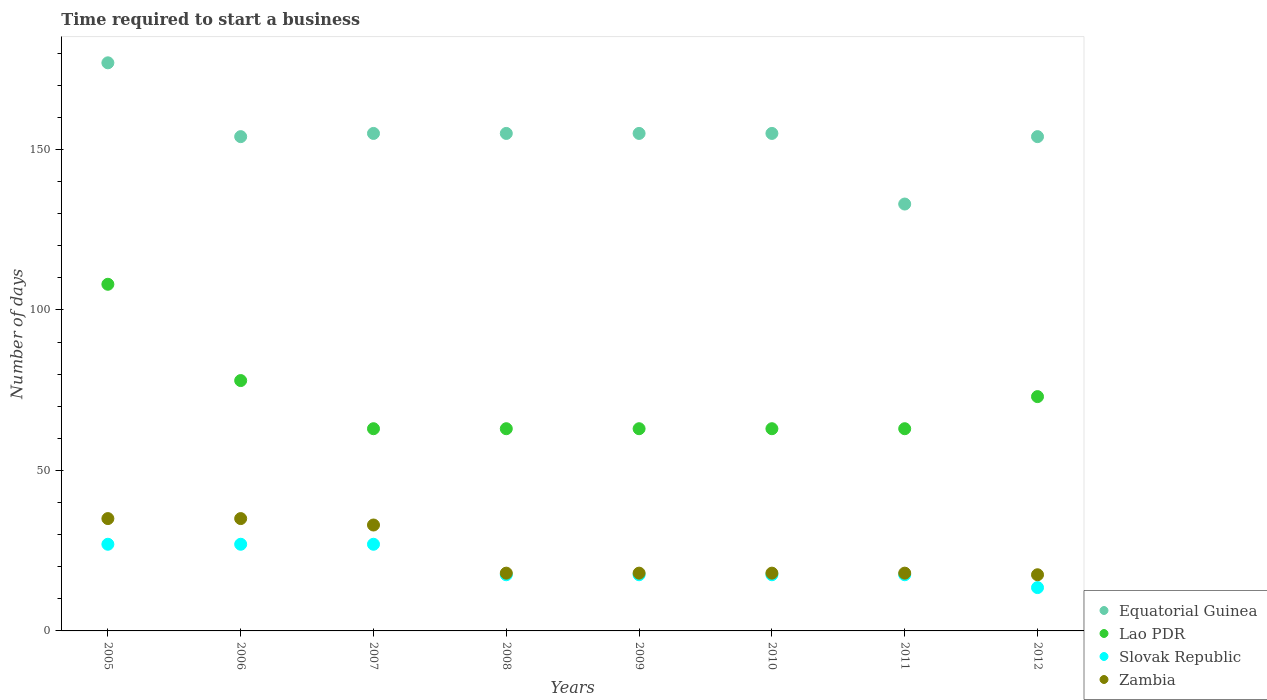What is the number of days required to start a business in Lao PDR in 2007?
Your answer should be very brief. 63. Across all years, what is the maximum number of days required to start a business in Slovak Republic?
Your answer should be very brief. 27. Across all years, what is the minimum number of days required to start a business in Equatorial Guinea?
Make the answer very short. 133. In which year was the number of days required to start a business in Slovak Republic maximum?
Ensure brevity in your answer.  2005. What is the total number of days required to start a business in Lao PDR in the graph?
Provide a succinct answer. 574. What is the difference between the number of days required to start a business in Slovak Republic in 2011 and that in 2012?
Keep it short and to the point. 4. What is the difference between the number of days required to start a business in Equatorial Guinea in 2005 and the number of days required to start a business in Zambia in 2008?
Ensure brevity in your answer.  159. What is the average number of days required to start a business in Lao PDR per year?
Your answer should be compact. 71.75. In the year 2012, what is the difference between the number of days required to start a business in Lao PDR and number of days required to start a business in Slovak Republic?
Your response must be concise. 59.5. What is the ratio of the number of days required to start a business in Zambia in 2007 to that in 2010?
Offer a very short reply. 1.83. Is the number of days required to start a business in Equatorial Guinea in 2006 less than that in 2011?
Your response must be concise. No. Is the difference between the number of days required to start a business in Lao PDR in 2009 and 2010 greater than the difference between the number of days required to start a business in Slovak Republic in 2009 and 2010?
Your answer should be very brief. No. What is the difference between the highest and the second highest number of days required to start a business in Lao PDR?
Offer a very short reply. 30. What is the difference between the highest and the lowest number of days required to start a business in Equatorial Guinea?
Your answer should be very brief. 44. How many dotlines are there?
Your answer should be very brief. 4. How many years are there in the graph?
Your answer should be very brief. 8. What is the difference between two consecutive major ticks on the Y-axis?
Provide a succinct answer. 50. What is the title of the graph?
Offer a very short reply. Time required to start a business. Does "Jordan" appear as one of the legend labels in the graph?
Your answer should be compact. No. What is the label or title of the Y-axis?
Make the answer very short. Number of days. What is the Number of days in Equatorial Guinea in 2005?
Offer a terse response. 177. What is the Number of days in Lao PDR in 2005?
Give a very brief answer. 108. What is the Number of days in Equatorial Guinea in 2006?
Keep it short and to the point. 154. What is the Number of days in Lao PDR in 2006?
Provide a short and direct response. 78. What is the Number of days of Slovak Republic in 2006?
Offer a very short reply. 27. What is the Number of days in Equatorial Guinea in 2007?
Give a very brief answer. 155. What is the Number of days in Equatorial Guinea in 2008?
Offer a very short reply. 155. What is the Number of days in Lao PDR in 2008?
Keep it short and to the point. 63. What is the Number of days in Zambia in 2008?
Your answer should be compact. 18. What is the Number of days in Equatorial Guinea in 2009?
Give a very brief answer. 155. What is the Number of days of Lao PDR in 2009?
Offer a very short reply. 63. What is the Number of days in Slovak Republic in 2009?
Your answer should be compact. 17.5. What is the Number of days of Zambia in 2009?
Make the answer very short. 18. What is the Number of days of Equatorial Guinea in 2010?
Provide a succinct answer. 155. What is the Number of days in Slovak Republic in 2010?
Keep it short and to the point. 17.5. What is the Number of days of Zambia in 2010?
Your answer should be compact. 18. What is the Number of days of Equatorial Guinea in 2011?
Your answer should be compact. 133. What is the Number of days of Slovak Republic in 2011?
Provide a succinct answer. 17.5. What is the Number of days of Zambia in 2011?
Make the answer very short. 18. What is the Number of days of Equatorial Guinea in 2012?
Your answer should be compact. 154. What is the Number of days in Lao PDR in 2012?
Your answer should be compact. 73. What is the Number of days of Slovak Republic in 2012?
Your response must be concise. 13.5. What is the Number of days of Zambia in 2012?
Make the answer very short. 17.5. Across all years, what is the maximum Number of days of Equatorial Guinea?
Offer a very short reply. 177. Across all years, what is the maximum Number of days of Lao PDR?
Make the answer very short. 108. Across all years, what is the minimum Number of days of Equatorial Guinea?
Offer a terse response. 133. Across all years, what is the minimum Number of days in Slovak Republic?
Offer a very short reply. 13.5. Across all years, what is the minimum Number of days in Zambia?
Offer a terse response. 17.5. What is the total Number of days in Equatorial Guinea in the graph?
Offer a terse response. 1238. What is the total Number of days of Lao PDR in the graph?
Your response must be concise. 574. What is the total Number of days of Slovak Republic in the graph?
Ensure brevity in your answer.  164.5. What is the total Number of days in Zambia in the graph?
Keep it short and to the point. 192.5. What is the difference between the Number of days in Slovak Republic in 2005 and that in 2006?
Provide a succinct answer. 0. What is the difference between the Number of days of Zambia in 2005 and that in 2006?
Ensure brevity in your answer.  0. What is the difference between the Number of days of Lao PDR in 2005 and that in 2008?
Provide a short and direct response. 45. What is the difference between the Number of days of Slovak Republic in 2005 and that in 2008?
Offer a very short reply. 9.5. What is the difference between the Number of days in Zambia in 2005 and that in 2008?
Offer a very short reply. 17. What is the difference between the Number of days in Equatorial Guinea in 2005 and that in 2009?
Give a very brief answer. 22. What is the difference between the Number of days of Slovak Republic in 2005 and that in 2009?
Your answer should be compact. 9.5. What is the difference between the Number of days of Zambia in 2005 and that in 2009?
Make the answer very short. 17. What is the difference between the Number of days in Zambia in 2005 and that in 2010?
Provide a succinct answer. 17. What is the difference between the Number of days of Equatorial Guinea in 2005 and that in 2011?
Your answer should be compact. 44. What is the difference between the Number of days of Lao PDR in 2005 and that in 2011?
Offer a very short reply. 45. What is the difference between the Number of days in Slovak Republic in 2005 and that in 2011?
Give a very brief answer. 9.5. What is the difference between the Number of days of Lao PDR in 2005 and that in 2012?
Provide a short and direct response. 35. What is the difference between the Number of days of Slovak Republic in 2005 and that in 2012?
Provide a short and direct response. 13.5. What is the difference between the Number of days of Lao PDR in 2006 and that in 2007?
Offer a very short reply. 15. What is the difference between the Number of days of Slovak Republic in 2006 and that in 2007?
Your answer should be very brief. 0. What is the difference between the Number of days of Zambia in 2006 and that in 2007?
Provide a succinct answer. 2. What is the difference between the Number of days of Equatorial Guinea in 2006 and that in 2009?
Your answer should be very brief. -1. What is the difference between the Number of days of Zambia in 2006 and that in 2009?
Give a very brief answer. 17. What is the difference between the Number of days in Equatorial Guinea in 2006 and that in 2010?
Keep it short and to the point. -1. What is the difference between the Number of days of Zambia in 2006 and that in 2010?
Provide a succinct answer. 17. What is the difference between the Number of days of Equatorial Guinea in 2006 and that in 2011?
Offer a terse response. 21. What is the difference between the Number of days in Slovak Republic in 2006 and that in 2011?
Ensure brevity in your answer.  9.5. What is the difference between the Number of days in Zambia in 2006 and that in 2011?
Give a very brief answer. 17. What is the difference between the Number of days of Equatorial Guinea in 2006 and that in 2012?
Your response must be concise. 0. What is the difference between the Number of days in Slovak Republic in 2006 and that in 2012?
Offer a terse response. 13.5. What is the difference between the Number of days in Zambia in 2006 and that in 2012?
Provide a succinct answer. 17.5. What is the difference between the Number of days of Lao PDR in 2007 and that in 2008?
Make the answer very short. 0. What is the difference between the Number of days of Zambia in 2007 and that in 2008?
Provide a succinct answer. 15. What is the difference between the Number of days in Lao PDR in 2007 and that in 2010?
Provide a succinct answer. 0. What is the difference between the Number of days in Slovak Republic in 2007 and that in 2010?
Your response must be concise. 9.5. What is the difference between the Number of days of Equatorial Guinea in 2007 and that in 2011?
Your answer should be very brief. 22. What is the difference between the Number of days of Lao PDR in 2007 and that in 2011?
Keep it short and to the point. 0. What is the difference between the Number of days in Slovak Republic in 2007 and that in 2012?
Your response must be concise. 13.5. What is the difference between the Number of days in Zambia in 2007 and that in 2012?
Provide a short and direct response. 15.5. What is the difference between the Number of days in Lao PDR in 2008 and that in 2009?
Make the answer very short. 0. What is the difference between the Number of days of Slovak Republic in 2008 and that in 2009?
Offer a terse response. 0. What is the difference between the Number of days of Lao PDR in 2008 and that in 2010?
Provide a short and direct response. 0. What is the difference between the Number of days of Zambia in 2008 and that in 2010?
Keep it short and to the point. 0. What is the difference between the Number of days of Slovak Republic in 2008 and that in 2012?
Give a very brief answer. 4. What is the difference between the Number of days in Equatorial Guinea in 2009 and that in 2010?
Your answer should be very brief. 0. What is the difference between the Number of days of Lao PDR in 2009 and that in 2010?
Provide a short and direct response. 0. What is the difference between the Number of days of Equatorial Guinea in 2009 and that in 2011?
Make the answer very short. 22. What is the difference between the Number of days of Lao PDR in 2009 and that in 2011?
Your response must be concise. 0. What is the difference between the Number of days in Slovak Republic in 2009 and that in 2011?
Your answer should be very brief. 0. What is the difference between the Number of days of Zambia in 2009 and that in 2011?
Provide a short and direct response. 0. What is the difference between the Number of days in Slovak Republic in 2009 and that in 2012?
Keep it short and to the point. 4. What is the difference between the Number of days of Zambia in 2009 and that in 2012?
Provide a succinct answer. 0.5. What is the difference between the Number of days of Slovak Republic in 2010 and that in 2011?
Make the answer very short. 0. What is the difference between the Number of days in Zambia in 2010 and that in 2011?
Ensure brevity in your answer.  0. What is the difference between the Number of days in Lao PDR in 2010 and that in 2012?
Make the answer very short. -10. What is the difference between the Number of days of Zambia in 2010 and that in 2012?
Offer a terse response. 0.5. What is the difference between the Number of days of Equatorial Guinea in 2005 and the Number of days of Slovak Republic in 2006?
Offer a very short reply. 150. What is the difference between the Number of days of Equatorial Guinea in 2005 and the Number of days of Zambia in 2006?
Ensure brevity in your answer.  142. What is the difference between the Number of days in Slovak Republic in 2005 and the Number of days in Zambia in 2006?
Keep it short and to the point. -8. What is the difference between the Number of days in Equatorial Guinea in 2005 and the Number of days in Lao PDR in 2007?
Provide a succinct answer. 114. What is the difference between the Number of days of Equatorial Guinea in 2005 and the Number of days of Slovak Republic in 2007?
Offer a terse response. 150. What is the difference between the Number of days of Equatorial Guinea in 2005 and the Number of days of Zambia in 2007?
Offer a very short reply. 144. What is the difference between the Number of days in Lao PDR in 2005 and the Number of days in Slovak Republic in 2007?
Keep it short and to the point. 81. What is the difference between the Number of days in Lao PDR in 2005 and the Number of days in Zambia in 2007?
Your response must be concise. 75. What is the difference between the Number of days of Equatorial Guinea in 2005 and the Number of days of Lao PDR in 2008?
Your answer should be compact. 114. What is the difference between the Number of days in Equatorial Guinea in 2005 and the Number of days in Slovak Republic in 2008?
Offer a very short reply. 159.5. What is the difference between the Number of days in Equatorial Guinea in 2005 and the Number of days in Zambia in 2008?
Ensure brevity in your answer.  159. What is the difference between the Number of days in Lao PDR in 2005 and the Number of days in Slovak Republic in 2008?
Offer a terse response. 90.5. What is the difference between the Number of days of Slovak Republic in 2005 and the Number of days of Zambia in 2008?
Provide a succinct answer. 9. What is the difference between the Number of days in Equatorial Guinea in 2005 and the Number of days in Lao PDR in 2009?
Your answer should be very brief. 114. What is the difference between the Number of days of Equatorial Guinea in 2005 and the Number of days of Slovak Republic in 2009?
Your answer should be very brief. 159.5. What is the difference between the Number of days of Equatorial Guinea in 2005 and the Number of days of Zambia in 2009?
Offer a very short reply. 159. What is the difference between the Number of days in Lao PDR in 2005 and the Number of days in Slovak Republic in 2009?
Ensure brevity in your answer.  90.5. What is the difference between the Number of days in Slovak Republic in 2005 and the Number of days in Zambia in 2009?
Give a very brief answer. 9. What is the difference between the Number of days of Equatorial Guinea in 2005 and the Number of days of Lao PDR in 2010?
Your response must be concise. 114. What is the difference between the Number of days of Equatorial Guinea in 2005 and the Number of days of Slovak Republic in 2010?
Keep it short and to the point. 159.5. What is the difference between the Number of days in Equatorial Guinea in 2005 and the Number of days in Zambia in 2010?
Offer a terse response. 159. What is the difference between the Number of days of Lao PDR in 2005 and the Number of days of Slovak Republic in 2010?
Provide a short and direct response. 90.5. What is the difference between the Number of days in Slovak Republic in 2005 and the Number of days in Zambia in 2010?
Provide a short and direct response. 9. What is the difference between the Number of days of Equatorial Guinea in 2005 and the Number of days of Lao PDR in 2011?
Offer a terse response. 114. What is the difference between the Number of days of Equatorial Guinea in 2005 and the Number of days of Slovak Republic in 2011?
Provide a short and direct response. 159.5. What is the difference between the Number of days in Equatorial Guinea in 2005 and the Number of days in Zambia in 2011?
Ensure brevity in your answer.  159. What is the difference between the Number of days in Lao PDR in 2005 and the Number of days in Slovak Republic in 2011?
Ensure brevity in your answer.  90.5. What is the difference between the Number of days of Lao PDR in 2005 and the Number of days of Zambia in 2011?
Keep it short and to the point. 90. What is the difference between the Number of days in Slovak Republic in 2005 and the Number of days in Zambia in 2011?
Make the answer very short. 9. What is the difference between the Number of days of Equatorial Guinea in 2005 and the Number of days of Lao PDR in 2012?
Your response must be concise. 104. What is the difference between the Number of days in Equatorial Guinea in 2005 and the Number of days in Slovak Republic in 2012?
Provide a short and direct response. 163.5. What is the difference between the Number of days in Equatorial Guinea in 2005 and the Number of days in Zambia in 2012?
Your answer should be very brief. 159.5. What is the difference between the Number of days of Lao PDR in 2005 and the Number of days of Slovak Republic in 2012?
Keep it short and to the point. 94.5. What is the difference between the Number of days in Lao PDR in 2005 and the Number of days in Zambia in 2012?
Give a very brief answer. 90.5. What is the difference between the Number of days of Equatorial Guinea in 2006 and the Number of days of Lao PDR in 2007?
Provide a succinct answer. 91. What is the difference between the Number of days of Equatorial Guinea in 2006 and the Number of days of Slovak Republic in 2007?
Provide a succinct answer. 127. What is the difference between the Number of days of Equatorial Guinea in 2006 and the Number of days of Zambia in 2007?
Offer a terse response. 121. What is the difference between the Number of days of Lao PDR in 2006 and the Number of days of Zambia in 2007?
Ensure brevity in your answer.  45. What is the difference between the Number of days of Slovak Republic in 2006 and the Number of days of Zambia in 2007?
Provide a short and direct response. -6. What is the difference between the Number of days in Equatorial Guinea in 2006 and the Number of days in Lao PDR in 2008?
Keep it short and to the point. 91. What is the difference between the Number of days in Equatorial Guinea in 2006 and the Number of days in Slovak Republic in 2008?
Provide a succinct answer. 136.5. What is the difference between the Number of days in Equatorial Guinea in 2006 and the Number of days in Zambia in 2008?
Offer a terse response. 136. What is the difference between the Number of days in Lao PDR in 2006 and the Number of days in Slovak Republic in 2008?
Keep it short and to the point. 60.5. What is the difference between the Number of days in Slovak Republic in 2006 and the Number of days in Zambia in 2008?
Give a very brief answer. 9. What is the difference between the Number of days of Equatorial Guinea in 2006 and the Number of days of Lao PDR in 2009?
Offer a terse response. 91. What is the difference between the Number of days of Equatorial Guinea in 2006 and the Number of days of Slovak Republic in 2009?
Keep it short and to the point. 136.5. What is the difference between the Number of days of Equatorial Guinea in 2006 and the Number of days of Zambia in 2009?
Your answer should be very brief. 136. What is the difference between the Number of days of Lao PDR in 2006 and the Number of days of Slovak Republic in 2009?
Ensure brevity in your answer.  60.5. What is the difference between the Number of days of Lao PDR in 2006 and the Number of days of Zambia in 2009?
Offer a terse response. 60. What is the difference between the Number of days in Slovak Republic in 2006 and the Number of days in Zambia in 2009?
Provide a short and direct response. 9. What is the difference between the Number of days of Equatorial Guinea in 2006 and the Number of days of Lao PDR in 2010?
Your answer should be compact. 91. What is the difference between the Number of days in Equatorial Guinea in 2006 and the Number of days in Slovak Republic in 2010?
Give a very brief answer. 136.5. What is the difference between the Number of days in Equatorial Guinea in 2006 and the Number of days in Zambia in 2010?
Provide a succinct answer. 136. What is the difference between the Number of days of Lao PDR in 2006 and the Number of days of Slovak Republic in 2010?
Your answer should be very brief. 60.5. What is the difference between the Number of days of Equatorial Guinea in 2006 and the Number of days of Lao PDR in 2011?
Your response must be concise. 91. What is the difference between the Number of days of Equatorial Guinea in 2006 and the Number of days of Slovak Republic in 2011?
Make the answer very short. 136.5. What is the difference between the Number of days in Equatorial Guinea in 2006 and the Number of days in Zambia in 2011?
Offer a terse response. 136. What is the difference between the Number of days in Lao PDR in 2006 and the Number of days in Slovak Republic in 2011?
Make the answer very short. 60.5. What is the difference between the Number of days of Lao PDR in 2006 and the Number of days of Zambia in 2011?
Give a very brief answer. 60. What is the difference between the Number of days in Equatorial Guinea in 2006 and the Number of days in Slovak Republic in 2012?
Offer a terse response. 140.5. What is the difference between the Number of days of Equatorial Guinea in 2006 and the Number of days of Zambia in 2012?
Provide a short and direct response. 136.5. What is the difference between the Number of days of Lao PDR in 2006 and the Number of days of Slovak Republic in 2012?
Provide a succinct answer. 64.5. What is the difference between the Number of days in Lao PDR in 2006 and the Number of days in Zambia in 2012?
Give a very brief answer. 60.5. What is the difference between the Number of days in Slovak Republic in 2006 and the Number of days in Zambia in 2012?
Your answer should be very brief. 9.5. What is the difference between the Number of days in Equatorial Guinea in 2007 and the Number of days in Lao PDR in 2008?
Your answer should be very brief. 92. What is the difference between the Number of days of Equatorial Guinea in 2007 and the Number of days of Slovak Republic in 2008?
Offer a very short reply. 137.5. What is the difference between the Number of days in Equatorial Guinea in 2007 and the Number of days in Zambia in 2008?
Give a very brief answer. 137. What is the difference between the Number of days in Lao PDR in 2007 and the Number of days in Slovak Republic in 2008?
Your answer should be compact. 45.5. What is the difference between the Number of days of Lao PDR in 2007 and the Number of days of Zambia in 2008?
Provide a succinct answer. 45. What is the difference between the Number of days of Slovak Republic in 2007 and the Number of days of Zambia in 2008?
Make the answer very short. 9. What is the difference between the Number of days in Equatorial Guinea in 2007 and the Number of days in Lao PDR in 2009?
Provide a succinct answer. 92. What is the difference between the Number of days of Equatorial Guinea in 2007 and the Number of days of Slovak Republic in 2009?
Provide a succinct answer. 137.5. What is the difference between the Number of days of Equatorial Guinea in 2007 and the Number of days of Zambia in 2009?
Provide a succinct answer. 137. What is the difference between the Number of days in Lao PDR in 2007 and the Number of days in Slovak Republic in 2009?
Provide a succinct answer. 45.5. What is the difference between the Number of days of Equatorial Guinea in 2007 and the Number of days of Lao PDR in 2010?
Provide a short and direct response. 92. What is the difference between the Number of days in Equatorial Guinea in 2007 and the Number of days in Slovak Republic in 2010?
Give a very brief answer. 137.5. What is the difference between the Number of days of Equatorial Guinea in 2007 and the Number of days of Zambia in 2010?
Offer a terse response. 137. What is the difference between the Number of days in Lao PDR in 2007 and the Number of days in Slovak Republic in 2010?
Offer a terse response. 45.5. What is the difference between the Number of days in Slovak Republic in 2007 and the Number of days in Zambia in 2010?
Make the answer very short. 9. What is the difference between the Number of days of Equatorial Guinea in 2007 and the Number of days of Lao PDR in 2011?
Keep it short and to the point. 92. What is the difference between the Number of days in Equatorial Guinea in 2007 and the Number of days in Slovak Republic in 2011?
Give a very brief answer. 137.5. What is the difference between the Number of days in Equatorial Guinea in 2007 and the Number of days in Zambia in 2011?
Give a very brief answer. 137. What is the difference between the Number of days of Lao PDR in 2007 and the Number of days of Slovak Republic in 2011?
Ensure brevity in your answer.  45.5. What is the difference between the Number of days in Lao PDR in 2007 and the Number of days in Zambia in 2011?
Your response must be concise. 45. What is the difference between the Number of days of Slovak Republic in 2007 and the Number of days of Zambia in 2011?
Give a very brief answer. 9. What is the difference between the Number of days in Equatorial Guinea in 2007 and the Number of days in Slovak Republic in 2012?
Your answer should be compact. 141.5. What is the difference between the Number of days of Equatorial Guinea in 2007 and the Number of days of Zambia in 2012?
Offer a terse response. 137.5. What is the difference between the Number of days of Lao PDR in 2007 and the Number of days of Slovak Republic in 2012?
Offer a very short reply. 49.5. What is the difference between the Number of days in Lao PDR in 2007 and the Number of days in Zambia in 2012?
Your response must be concise. 45.5. What is the difference between the Number of days of Equatorial Guinea in 2008 and the Number of days of Lao PDR in 2009?
Keep it short and to the point. 92. What is the difference between the Number of days of Equatorial Guinea in 2008 and the Number of days of Slovak Republic in 2009?
Provide a succinct answer. 137.5. What is the difference between the Number of days in Equatorial Guinea in 2008 and the Number of days in Zambia in 2009?
Your answer should be compact. 137. What is the difference between the Number of days of Lao PDR in 2008 and the Number of days of Slovak Republic in 2009?
Make the answer very short. 45.5. What is the difference between the Number of days of Lao PDR in 2008 and the Number of days of Zambia in 2009?
Offer a terse response. 45. What is the difference between the Number of days in Slovak Republic in 2008 and the Number of days in Zambia in 2009?
Offer a terse response. -0.5. What is the difference between the Number of days of Equatorial Guinea in 2008 and the Number of days of Lao PDR in 2010?
Offer a very short reply. 92. What is the difference between the Number of days of Equatorial Guinea in 2008 and the Number of days of Slovak Republic in 2010?
Your answer should be very brief. 137.5. What is the difference between the Number of days of Equatorial Guinea in 2008 and the Number of days of Zambia in 2010?
Keep it short and to the point. 137. What is the difference between the Number of days in Lao PDR in 2008 and the Number of days in Slovak Republic in 2010?
Make the answer very short. 45.5. What is the difference between the Number of days of Slovak Republic in 2008 and the Number of days of Zambia in 2010?
Offer a terse response. -0.5. What is the difference between the Number of days of Equatorial Guinea in 2008 and the Number of days of Lao PDR in 2011?
Offer a terse response. 92. What is the difference between the Number of days of Equatorial Guinea in 2008 and the Number of days of Slovak Republic in 2011?
Provide a succinct answer. 137.5. What is the difference between the Number of days of Equatorial Guinea in 2008 and the Number of days of Zambia in 2011?
Provide a short and direct response. 137. What is the difference between the Number of days of Lao PDR in 2008 and the Number of days of Slovak Republic in 2011?
Offer a very short reply. 45.5. What is the difference between the Number of days in Lao PDR in 2008 and the Number of days in Zambia in 2011?
Offer a terse response. 45. What is the difference between the Number of days in Slovak Republic in 2008 and the Number of days in Zambia in 2011?
Your response must be concise. -0.5. What is the difference between the Number of days in Equatorial Guinea in 2008 and the Number of days in Slovak Republic in 2012?
Make the answer very short. 141.5. What is the difference between the Number of days in Equatorial Guinea in 2008 and the Number of days in Zambia in 2012?
Make the answer very short. 137.5. What is the difference between the Number of days in Lao PDR in 2008 and the Number of days in Slovak Republic in 2012?
Your answer should be very brief. 49.5. What is the difference between the Number of days in Lao PDR in 2008 and the Number of days in Zambia in 2012?
Provide a succinct answer. 45.5. What is the difference between the Number of days of Equatorial Guinea in 2009 and the Number of days of Lao PDR in 2010?
Your answer should be very brief. 92. What is the difference between the Number of days in Equatorial Guinea in 2009 and the Number of days in Slovak Republic in 2010?
Your answer should be compact. 137.5. What is the difference between the Number of days in Equatorial Guinea in 2009 and the Number of days in Zambia in 2010?
Your response must be concise. 137. What is the difference between the Number of days of Lao PDR in 2009 and the Number of days of Slovak Republic in 2010?
Keep it short and to the point. 45.5. What is the difference between the Number of days in Lao PDR in 2009 and the Number of days in Zambia in 2010?
Your answer should be compact. 45. What is the difference between the Number of days in Slovak Republic in 2009 and the Number of days in Zambia in 2010?
Offer a terse response. -0.5. What is the difference between the Number of days of Equatorial Guinea in 2009 and the Number of days of Lao PDR in 2011?
Give a very brief answer. 92. What is the difference between the Number of days of Equatorial Guinea in 2009 and the Number of days of Slovak Republic in 2011?
Ensure brevity in your answer.  137.5. What is the difference between the Number of days of Equatorial Guinea in 2009 and the Number of days of Zambia in 2011?
Your answer should be very brief. 137. What is the difference between the Number of days of Lao PDR in 2009 and the Number of days of Slovak Republic in 2011?
Provide a succinct answer. 45.5. What is the difference between the Number of days of Lao PDR in 2009 and the Number of days of Zambia in 2011?
Provide a short and direct response. 45. What is the difference between the Number of days in Equatorial Guinea in 2009 and the Number of days in Lao PDR in 2012?
Ensure brevity in your answer.  82. What is the difference between the Number of days of Equatorial Guinea in 2009 and the Number of days of Slovak Republic in 2012?
Make the answer very short. 141.5. What is the difference between the Number of days of Equatorial Guinea in 2009 and the Number of days of Zambia in 2012?
Your response must be concise. 137.5. What is the difference between the Number of days of Lao PDR in 2009 and the Number of days of Slovak Republic in 2012?
Make the answer very short. 49.5. What is the difference between the Number of days in Lao PDR in 2009 and the Number of days in Zambia in 2012?
Make the answer very short. 45.5. What is the difference between the Number of days of Equatorial Guinea in 2010 and the Number of days of Lao PDR in 2011?
Give a very brief answer. 92. What is the difference between the Number of days in Equatorial Guinea in 2010 and the Number of days in Slovak Republic in 2011?
Give a very brief answer. 137.5. What is the difference between the Number of days of Equatorial Guinea in 2010 and the Number of days of Zambia in 2011?
Your answer should be compact. 137. What is the difference between the Number of days of Lao PDR in 2010 and the Number of days of Slovak Republic in 2011?
Offer a terse response. 45.5. What is the difference between the Number of days of Lao PDR in 2010 and the Number of days of Zambia in 2011?
Make the answer very short. 45. What is the difference between the Number of days in Equatorial Guinea in 2010 and the Number of days in Lao PDR in 2012?
Keep it short and to the point. 82. What is the difference between the Number of days of Equatorial Guinea in 2010 and the Number of days of Slovak Republic in 2012?
Your answer should be very brief. 141.5. What is the difference between the Number of days of Equatorial Guinea in 2010 and the Number of days of Zambia in 2012?
Ensure brevity in your answer.  137.5. What is the difference between the Number of days in Lao PDR in 2010 and the Number of days in Slovak Republic in 2012?
Keep it short and to the point. 49.5. What is the difference between the Number of days of Lao PDR in 2010 and the Number of days of Zambia in 2012?
Ensure brevity in your answer.  45.5. What is the difference between the Number of days of Equatorial Guinea in 2011 and the Number of days of Slovak Republic in 2012?
Your response must be concise. 119.5. What is the difference between the Number of days in Equatorial Guinea in 2011 and the Number of days in Zambia in 2012?
Keep it short and to the point. 115.5. What is the difference between the Number of days in Lao PDR in 2011 and the Number of days in Slovak Republic in 2012?
Your answer should be compact. 49.5. What is the difference between the Number of days in Lao PDR in 2011 and the Number of days in Zambia in 2012?
Provide a succinct answer. 45.5. What is the difference between the Number of days in Slovak Republic in 2011 and the Number of days in Zambia in 2012?
Offer a terse response. 0. What is the average Number of days in Equatorial Guinea per year?
Keep it short and to the point. 154.75. What is the average Number of days in Lao PDR per year?
Keep it short and to the point. 71.75. What is the average Number of days in Slovak Republic per year?
Provide a short and direct response. 20.56. What is the average Number of days in Zambia per year?
Give a very brief answer. 24.06. In the year 2005, what is the difference between the Number of days in Equatorial Guinea and Number of days in Slovak Republic?
Offer a very short reply. 150. In the year 2005, what is the difference between the Number of days in Equatorial Guinea and Number of days in Zambia?
Make the answer very short. 142. In the year 2005, what is the difference between the Number of days of Lao PDR and Number of days of Slovak Republic?
Give a very brief answer. 81. In the year 2006, what is the difference between the Number of days in Equatorial Guinea and Number of days in Slovak Republic?
Keep it short and to the point. 127. In the year 2006, what is the difference between the Number of days in Equatorial Guinea and Number of days in Zambia?
Ensure brevity in your answer.  119. In the year 2006, what is the difference between the Number of days of Lao PDR and Number of days of Slovak Republic?
Make the answer very short. 51. In the year 2006, what is the difference between the Number of days of Lao PDR and Number of days of Zambia?
Offer a terse response. 43. In the year 2007, what is the difference between the Number of days of Equatorial Guinea and Number of days of Lao PDR?
Your response must be concise. 92. In the year 2007, what is the difference between the Number of days in Equatorial Guinea and Number of days in Slovak Republic?
Your answer should be compact. 128. In the year 2007, what is the difference between the Number of days in Equatorial Guinea and Number of days in Zambia?
Your answer should be compact. 122. In the year 2007, what is the difference between the Number of days of Lao PDR and Number of days of Slovak Republic?
Your response must be concise. 36. In the year 2007, what is the difference between the Number of days of Lao PDR and Number of days of Zambia?
Offer a terse response. 30. In the year 2007, what is the difference between the Number of days in Slovak Republic and Number of days in Zambia?
Your answer should be very brief. -6. In the year 2008, what is the difference between the Number of days in Equatorial Guinea and Number of days in Lao PDR?
Ensure brevity in your answer.  92. In the year 2008, what is the difference between the Number of days of Equatorial Guinea and Number of days of Slovak Republic?
Make the answer very short. 137.5. In the year 2008, what is the difference between the Number of days of Equatorial Guinea and Number of days of Zambia?
Your response must be concise. 137. In the year 2008, what is the difference between the Number of days in Lao PDR and Number of days in Slovak Republic?
Provide a short and direct response. 45.5. In the year 2008, what is the difference between the Number of days in Slovak Republic and Number of days in Zambia?
Make the answer very short. -0.5. In the year 2009, what is the difference between the Number of days of Equatorial Guinea and Number of days of Lao PDR?
Give a very brief answer. 92. In the year 2009, what is the difference between the Number of days of Equatorial Guinea and Number of days of Slovak Republic?
Keep it short and to the point. 137.5. In the year 2009, what is the difference between the Number of days in Equatorial Guinea and Number of days in Zambia?
Keep it short and to the point. 137. In the year 2009, what is the difference between the Number of days in Lao PDR and Number of days in Slovak Republic?
Your answer should be compact. 45.5. In the year 2009, what is the difference between the Number of days in Lao PDR and Number of days in Zambia?
Keep it short and to the point. 45. In the year 2010, what is the difference between the Number of days of Equatorial Guinea and Number of days of Lao PDR?
Your answer should be very brief. 92. In the year 2010, what is the difference between the Number of days in Equatorial Guinea and Number of days in Slovak Republic?
Offer a terse response. 137.5. In the year 2010, what is the difference between the Number of days in Equatorial Guinea and Number of days in Zambia?
Provide a succinct answer. 137. In the year 2010, what is the difference between the Number of days in Lao PDR and Number of days in Slovak Republic?
Your answer should be very brief. 45.5. In the year 2011, what is the difference between the Number of days in Equatorial Guinea and Number of days in Slovak Republic?
Provide a short and direct response. 115.5. In the year 2011, what is the difference between the Number of days in Equatorial Guinea and Number of days in Zambia?
Give a very brief answer. 115. In the year 2011, what is the difference between the Number of days in Lao PDR and Number of days in Slovak Republic?
Give a very brief answer. 45.5. In the year 2011, what is the difference between the Number of days in Lao PDR and Number of days in Zambia?
Offer a very short reply. 45. In the year 2012, what is the difference between the Number of days of Equatorial Guinea and Number of days of Slovak Republic?
Keep it short and to the point. 140.5. In the year 2012, what is the difference between the Number of days of Equatorial Guinea and Number of days of Zambia?
Your response must be concise. 136.5. In the year 2012, what is the difference between the Number of days in Lao PDR and Number of days in Slovak Republic?
Keep it short and to the point. 59.5. In the year 2012, what is the difference between the Number of days in Lao PDR and Number of days in Zambia?
Make the answer very short. 55.5. What is the ratio of the Number of days in Equatorial Guinea in 2005 to that in 2006?
Your answer should be very brief. 1.15. What is the ratio of the Number of days of Lao PDR in 2005 to that in 2006?
Make the answer very short. 1.38. What is the ratio of the Number of days of Slovak Republic in 2005 to that in 2006?
Ensure brevity in your answer.  1. What is the ratio of the Number of days in Equatorial Guinea in 2005 to that in 2007?
Your response must be concise. 1.14. What is the ratio of the Number of days in Lao PDR in 2005 to that in 2007?
Give a very brief answer. 1.71. What is the ratio of the Number of days in Zambia in 2005 to that in 2007?
Give a very brief answer. 1.06. What is the ratio of the Number of days in Equatorial Guinea in 2005 to that in 2008?
Provide a short and direct response. 1.14. What is the ratio of the Number of days of Lao PDR in 2005 to that in 2008?
Ensure brevity in your answer.  1.71. What is the ratio of the Number of days in Slovak Republic in 2005 to that in 2008?
Make the answer very short. 1.54. What is the ratio of the Number of days of Zambia in 2005 to that in 2008?
Your response must be concise. 1.94. What is the ratio of the Number of days in Equatorial Guinea in 2005 to that in 2009?
Your answer should be very brief. 1.14. What is the ratio of the Number of days in Lao PDR in 2005 to that in 2009?
Give a very brief answer. 1.71. What is the ratio of the Number of days of Slovak Republic in 2005 to that in 2009?
Keep it short and to the point. 1.54. What is the ratio of the Number of days in Zambia in 2005 to that in 2009?
Provide a succinct answer. 1.94. What is the ratio of the Number of days in Equatorial Guinea in 2005 to that in 2010?
Make the answer very short. 1.14. What is the ratio of the Number of days in Lao PDR in 2005 to that in 2010?
Provide a succinct answer. 1.71. What is the ratio of the Number of days of Slovak Republic in 2005 to that in 2010?
Your answer should be compact. 1.54. What is the ratio of the Number of days in Zambia in 2005 to that in 2010?
Make the answer very short. 1.94. What is the ratio of the Number of days in Equatorial Guinea in 2005 to that in 2011?
Keep it short and to the point. 1.33. What is the ratio of the Number of days in Lao PDR in 2005 to that in 2011?
Give a very brief answer. 1.71. What is the ratio of the Number of days of Slovak Republic in 2005 to that in 2011?
Ensure brevity in your answer.  1.54. What is the ratio of the Number of days in Zambia in 2005 to that in 2011?
Your response must be concise. 1.94. What is the ratio of the Number of days of Equatorial Guinea in 2005 to that in 2012?
Make the answer very short. 1.15. What is the ratio of the Number of days in Lao PDR in 2005 to that in 2012?
Ensure brevity in your answer.  1.48. What is the ratio of the Number of days of Lao PDR in 2006 to that in 2007?
Provide a succinct answer. 1.24. What is the ratio of the Number of days in Zambia in 2006 to that in 2007?
Make the answer very short. 1.06. What is the ratio of the Number of days of Lao PDR in 2006 to that in 2008?
Your response must be concise. 1.24. What is the ratio of the Number of days of Slovak Republic in 2006 to that in 2008?
Your response must be concise. 1.54. What is the ratio of the Number of days of Zambia in 2006 to that in 2008?
Ensure brevity in your answer.  1.94. What is the ratio of the Number of days of Lao PDR in 2006 to that in 2009?
Keep it short and to the point. 1.24. What is the ratio of the Number of days in Slovak Republic in 2006 to that in 2009?
Your response must be concise. 1.54. What is the ratio of the Number of days in Zambia in 2006 to that in 2009?
Offer a terse response. 1.94. What is the ratio of the Number of days in Lao PDR in 2006 to that in 2010?
Offer a very short reply. 1.24. What is the ratio of the Number of days of Slovak Republic in 2006 to that in 2010?
Your answer should be compact. 1.54. What is the ratio of the Number of days in Zambia in 2006 to that in 2010?
Offer a terse response. 1.94. What is the ratio of the Number of days in Equatorial Guinea in 2006 to that in 2011?
Ensure brevity in your answer.  1.16. What is the ratio of the Number of days in Lao PDR in 2006 to that in 2011?
Your response must be concise. 1.24. What is the ratio of the Number of days in Slovak Republic in 2006 to that in 2011?
Your response must be concise. 1.54. What is the ratio of the Number of days in Zambia in 2006 to that in 2011?
Keep it short and to the point. 1.94. What is the ratio of the Number of days in Equatorial Guinea in 2006 to that in 2012?
Offer a very short reply. 1. What is the ratio of the Number of days in Lao PDR in 2006 to that in 2012?
Offer a terse response. 1.07. What is the ratio of the Number of days of Lao PDR in 2007 to that in 2008?
Provide a succinct answer. 1. What is the ratio of the Number of days in Slovak Republic in 2007 to that in 2008?
Give a very brief answer. 1.54. What is the ratio of the Number of days in Zambia in 2007 to that in 2008?
Keep it short and to the point. 1.83. What is the ratio of the Number of days of Equatorial Guinea in 2007 to that in 2009?
Your answer should be very brief. 1. What is the ratio of the Number of days of Lao PDR in 2007 to that in 2009?
Provide a succinct answer. 1. What is the ratio of the Number of days of Slovak Republic in 2007 to that in 2009?
Give a very brief answer. 1.54. What is the ratio of the Number of days of Zambia in 2007 to that in 2009?
Offer a very short reply. 1.83. What is the ratio of the Number of days of Slovak Republic in 2007 to that in 2010?
Ensure brevity in your answer.  1.54. What is the ratio of the Number of days of Zambia in 2007 to that in 2010?
Keep it short and to the point. 1.83. What is the ratio of the Number of days of Equatorial Guinea in 2007 to that in 2011?
Give a very brief answer. 1.17. What is the ratio of the Number of days of Lao PDR in 2007 to that in 2011?
Your answer should be compact. 1. What is the ratio of the Number of days in Slovak Republic in 2007 to that in 2011?
Ensure brevity in your answer.  1.54. What is the ratio of the Number of days in Zambia in 2007 to that in 2011?
Offer a very short reply. 1.83. What is the ratio of the Number of days of Equatorial Guinea in 2007 to that in 2012?
Your answer should be very brief. 1.01. What is the ratio of the Number of days of Lao PDR in 2007 to that in 2012?
Keep it short and to the point. 0.86. What is the ratio of the Number of days of Zambia in 2007 to that in 2012?
Your answer should be very brief. 1.89. What is the ratio of the Number of days of Equatorial Guinea in 2008 to that in 2009?
Your answer should be compact. 1. What is the ratio of the Number of days of Lao PDR in 2008 to that in 2009?
Offer a terse response. 1. What is the ratio of the Number of days in Slovak Republic in 2008 to that in 2009?
Your answer should be very brief. 1. What is the ratio of the Number of days of Zambia in 2008 to that in 2009?
Give a very brief answer. 1. What is the ratio of the Number of days in Zambia in 2008 to that in 2010?
Ensure brevity in your answer.  1. What is the ratio of the Number of days of Equatorial Guinea in 2008 to that in 2011?
Offer a terse response. 1.17. What is the ratio of the Number of days of Lao PDR in 2008 to that in 2011?
Provide a succinct answer. 1. What is the ratio of the Number of days in Zambia in 2008 to that in 2011?
Your answer should be compact. 1. What is the ratio of the Number of days of Equatorial Guinea in 2008 to that in 2012?
Provide a succinct answer. 1.01. What is the ratio of the Number of days in Lao PDR in 2008 to that in 2012?
Make the answer very short. 0.86. What is the ratio of the Number of days in Slovak Republic in 2008 to that in 2012?
Make the answer very short. 1.3. What is the ratio of the Number of days of Zambia in 2008 to that in 2012?
Provide a succinct answer. 1.03. What is the ratio of the Number of days of Slovak Republic in 2009 to that in 2010?
Provide a succinct answer. 1. What is the ratio of the Number of days in Zambia in 2009 to that in 2010?
Your response must be concise. 1. What is the ratio of the Number of days in Equatorial Guinea in 2009 to that in 2011?
Your response must be concise. 1.17. What is the ratio of the Number of days of Lao PDR in 2009 to that in 2011?
Provide a succinct answer. 1. What is the ratio of the Number of days of Zambia in 2009 to that in 2011?
Make the answer very short. 1. What is the ratio of the Number of days of Equatorial Guinea in 2009 to that in 2012?
Your response must be concise. 1.01. What is the ratio of the Number of days of Lao PDR in 2009 to that in 2012?
Your answer should be very brief. 0.86. What is the ratio of the Number of days in Slovak Republic in 2009 to that in 2012?
Offer a terse response. 1.3. What is the ratio of the Number of days in Zambia in 2009 to that in 2012?
Give a very brief answer. 1.03. What is the ratio of the Number of days of Equatorial Guinea in 2010 to that in 2011?
Your answer should be very brief. 1.17. What is the ratio of the Number of days of Slovak Republic in 2010 to that in 2011?
Provide a succinct answer. 1. What is the ratio of the Number of days in Zambia in 2010 to that in 2011?
Provide a succinct answer. 1. What is the ratio of the Number of days in Equatorial Guinea in 2010 to that in 2012?
Your answer should be compact. 1.01. What is the ratio of the Number of days of Lao PDR in 2010 to that in 2012?
Give a very brief answer. 0.86. What is the ratio of the Number of days of Slovak Republic in 2010 to that in 2012?
Ensure brevity in your answer.  1.3. What is the ratio of the Number of days in Zambia in 2010 to that in 2012?
Provide a short and direct response. 1.03. What is the ratio of the Number of days in Equatorial Guinea in 2011 to that in 2012?
Your answer should be very brief. 0.86. What is the ratio of the Number of days in Lao PDR in 2011 to that in 2012?
Offer a very short reply. 0.86. What is the ratio of the Number of days in Slovak Republic in 2011 to that in 2012?
Offer a very short reply. 1.3. What is the ratio of the Number of days in Zambia in 2011 to that in 2012?
Your response must be concise. 1.03. What is the difference between the highest and the second highest Number of days of Lao PDR?
Provide a short and direct response. 30. What is the difference between the highest and the second highest Number of days of Zambia?
Ensure brevity in your answer.  0. What is the difference between the highest and the lowest Number of days of Equatorial Guinea?
Your answer should be very brief. 44. What is the difference between the highest and the lowest Number of days of Lao PDR?
Give a very brief answer. 45. What is the difference between the highest and the lowest Number of days in Slovak Republic?
Provide a succinct answer. 13.5. What is the difference between the highest and the lowest Number of days of Zambia?
Your response must be concise. 17.5. 